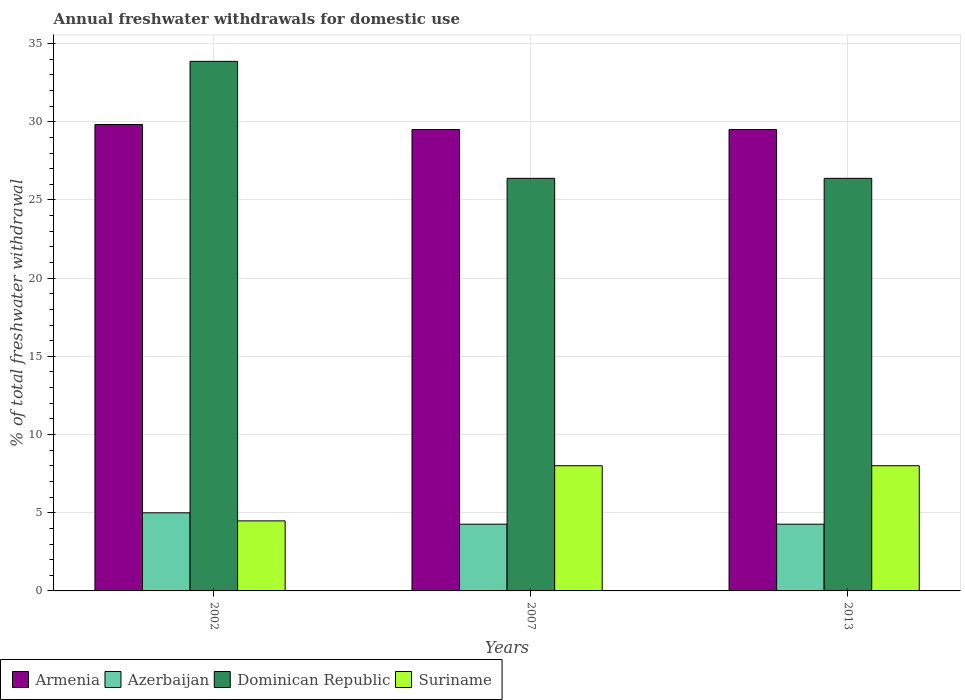How many groups of bars are there?
Keep it short and to the point. 3. Are the number of bars per tick equal to the number of legend labels?
Ensure brevity in your answer.  Yes. Are the number of bars on each tick of the X-axis equal?
Make the answer very short. Yes. How many bars are there on the 1st tick from the left?
Give a very brief answer. 4. How many bars are there on the 3rd tick from the right?
Provide a short and direct response. 4. In how many cases, is the number of bars for a given year not equal to the number of legend labels?
Provide a succinct answer. 0. What is the total annual withdrawals from freshwater in Armenia in 2013?
Your answer should be very brief. 29.5. Across all years, what is the maximum total annual withdrawals from freshwater in Suriname?
Your response must be concise. 8.01. Across all years, what is the minimum total annual withdrawals from freshwater in Dominican Republic?
Your answer should be very brief. 26.38. What is the total total annual withdrawals from freshwater in Suriname in the graph?
Your response must be concise. 20.49. What is the difference between the total annual withdrawals from freshwater in Suriname in 2002 and that in 2013?
Provide a short and direct response. -3.53. What is the difference between the total annual withdrawals from freshwater in Suriname in 2007 and the total annual withdrawals from freshwater in Azerbaijan in 2002?
Your response must be concise. 3.01. What is the average total annual withdrawals from freshwater in Suriname per year?
Ensure brevity in your answer.  6.83. In the year 2002, what is the difference between the total annual withdrawals from freshwater in Armenia and total annual withdrawals from freshwater in Azerbaijan?
Offer a terse response. 24.82. In how many years, is the total annual withdrawals from freshwater in Azerbaijan greater than 25 %?
Make the answer very short. 0. What is the ratio of the total annual withdrawals from freshwater in Azerbaijan in 2007 to that in 2013?
Provide a short and direct response. 1. Is the total annual withdrawals from freshwater in Armenia in 2007 less than that in 2013?
Provide a short and direct response. No. Is the difference between the total annual withdrawals from freshwater in Armenia in 2007 and 2013 greater than the difference between the total annual withdrawals from freshwater in Azerbaijan in 2007 and 2013?
Offer a very short reply. No. What is the difference between the highest and the lowest total annual withdrawals from freshwater in Azerbaijan?
Keep it short and to the point. 0.73. In how many years, is the total annual withdrawals from freshwater in Suriname greater than the average total annual withdrawals from freshwater in Suriname taken over all years?
Your response must be concise. 2. Is the sum of the total annual withdrawals from freshwater in Dominican Republic in 2007 and 2013 greater than the maximum total annual withdrawals from freshwater in Suriname across all years?
Give a very brief answer. Yes. Is it the case that in every year, the sum of the total annual withdrawals from freshwater in Dominican Republic and total annual withdrawals from freshwater in Armenia is greater than the sum of total annual withdrawals from freshwater in Suriname and total annual withdrawals from freshwater in Azerbaijan?
Your answer should be very brief. Yes. What does the 4th bar from the left in 2002 represents?
Offer a terse response. Suriname. What does the 4th bar from the right in 2007 represents?
Offer a very short reply. Armenia. Is it the case that in every year, the sum of the total annual withdrawals from freshwater in Armenia and total annual withdrawals from freshwater in Suriname is greater than the total annual withdrawals from freshwater in Dominican Republic?
Keep it short and to the point. Yes. Are all the bars in the graph horizontal?
Offer a terse response. No. How many years are there in the graph?
Your answer should be compact. 3. Are the values on the major ticks of Y-axis written in scientific E-notation?
Provide a short and direct response. No. Does the graph contain any zero values?
Provide a short and direct response. No. Where does the legend appear in the graph?
Offer a very short reply. Bottom left. How many legend labels are there?
Make the answer very short. 4. What is the title of the graph?
Make the answer very short. Annual freshwater withdrawals for domestic use. What is the label or title of the X-axis?
Provide a succinct answer. Years. What is the label or title of the Y-axis?
Offer a terse response. % of total freshwater withdrawal. What is the % of total freshwater withdrawal of Armenia in 2002?
Provide a succinct answer. 29.82. What is the % of total freshwater withdrawal of Azerbaijan in 2002?
Offer a terse response. 5. What is the % of total freshwater withdrawal in Dominican Republic in 2002?
Keep it short and to the point. 33.86. What is the % of total freshwater withdrawal in Suriname in 2002?
Provide a short and direct response. 4.48. What is the % of total freshwater withdrawal of Armenia in 2007?
Give a very brief answer. 29.5. What is the % of total freshwater withdrawal of Azerbaijan in 2007?
Your answer should be very brief. 4.27. What is the % of total freshwater withdrawal of Dominican Republic in 2007?
Your answer should be compact. 26.38. What is the % of total freshwater withdrawal of Suriname in 2007?
Offer a very short reply. 8.01. What is the % of total freshwater withdrawal in Armenia in 2013?
Provide a short and direct response. 29.5. What is the % of total freshwater withdrawal of Azerbaijan in 2013?
Your response must be concise. 4.27. What is the % of total freshwater withdrawal of Dominican Republic in 2013?
Give a very brief answer. 26.38. What is the % of total freshwater withdrawal in Suriname in 2013?
Provide a short and direct response. 8.01. Across all years, what is the maximum % of total freshwater withdrawal in Armenia?
Ensure brevity in your answer.  29.82. Across all years, what is the maximum % of total freshwater withdrawal of Azerbaijan?
Keep it short and to the point. 5. Across all years, what is the maximum % of total freshwater withdrawal of Dominican Republic?
Keep it short and to the point. 33.86. Across all years, what is the maximum % of total freshwater withdrawal in Suriname?
Your answer should be very brief. 8.01. Across all years, what is the minimum % of total freshwater withdrawal in Armenia?
Ensure brevity in your answer.  29.5. Across all years, what is the minimum % of total freshwater withdrawal of Azerbaijan?
Offer a terse response. 4.27. Across all years, what is the minimum % of total freshwater withdrawal of Dominican Republic?
Offer a terse response. 26.38. Across all years, what is the minimum % of total freshwater withdrawal of Suriname?
Your answer should be compact. 4.48. What is the total % of total freshwater withdrawal in Armenia in the graph?
Keep it short and to the point. 88.82. What is the total % of total freshwater withdrawal of Azerbaijan in the graph?
Keep it short and to the point. 13.53. What is the total % of total freshwater withdrawal of Dominican Republic in the graph?
Make the answer very short. 86.62. What is the total % of total freshwater withdrawal in Suriname in the graph?
Offer a very short reply. 20.49. What is the difference between the % of total freshwater withdrawal of Armenia in 2002 and that in 2007?
Ensure brevity in your answer.  0.32. What is the difference between the % of total freshwater withdrawal in Azerbaijan in 2002 and that in 2007?
Ensure brevity in your answer.  0.73. What is the difference between the % of total freshwater withdrawal in Dominican Republic in 2002 and that in 2007?
Offer a terse response. 7.48. What is the difference between the % of total freshwater withdrawal in Suriname in 2002 and that in 2007?
Keep it short and to the point. -3.53. What is the difference between the % of total freshwater withdrawal of Armenia in 2002 and that in 2013?
Offer a terse response. 0.32. What is the difference between the % of total freshwater withdrawal of Azerbaijan in 2002 and that in 2013?
Give a very brief answer. 0.73. What is the difference between the % of total freshwater withdrawal in Dominican Republic in 2002 and that in 2013?
Give a very brief answer. 7.48. What is the difference between the % of total freshwater withdrawal of Suriname in 2002 and that in 2013?
Ensure brevity in your answer.  -3.53. What is the difference between the % of total freshwater withdrawal of Azerbaijan in 2007 and that in 2013?
Your answer should be very brief. 0. What is the difference between the % of total freshwater withdrawal in Dominican Republic in 2007 and that in 2013?
Provide a short and direct response. 0. What is the difference between the % of total freshwater withdrawal of Suriname in 2007 and that in 2013?
Offer a very short reply. 0. What is the difference between the % of total freshwater withdrawal of Armenia in 2002 and the % of total freshwater withdrawal of Azerbaijan in 2007?
Provide a short and direct response. 25.55. What is the difference between the % of total freshwater withdrawal in Armenia in 2002 and the % of total freshwater withdrawal in Dominican Republic in 2007?
Offer a terse response. 3.44. What is the difference between the % of total freshwater withdrawal of Armenia in 2002 and the % of total freshwater withdrawal of Suriname in 2007?
Provide a succinct answer. 21.82. What is the difference between the % of total freshwater withdrawal of Azerbaijan in 2002 and the % of total freshwater withdrawal of Dominican Republic in 2007?
Your response must be concise. -21.39. What is the difference between the % of total freshwater withdrawal of Azerbaijan in 2002 and the % of total freshwater withdrawal of Suriname in 2007?
Keep it short and to the point. -3.01. What is the difference between the % of total freshwater withdrawal of Dominican Republic in 2002 and the % of total freshwater withdrawal of Suriname in 2007?
Make the answer very short. 25.86. What is the difference between the % of total freshwater withdrawal in Armenia in 2002 and the % of total freshwater withdrawal in Azerbaijan in 2013?
Offer a terse response. 25.55. What is the difference between the % of total freshwater withdrawal in Armenia in 2002 and the % of total freshwater withdrawal in Dominican Republic in 2013?
Offer a very short reply. 3.44. What is the difference between the % of total freshwater withdrawal in Armenia in 2002 and the % of total freshwater withdrawal in Suriname in 2013?
Ensure brevity in your answer.  21.82. What is the difference between the % of total freshwater withdrawal in Azerbaijan in 2002 and the % of total freshwater withdrawal in Dominican Republic in 2013?
Keep it short and to the point. -21.39. What is the difference between the % of total freshwater withdrawal of Azerbaijan in 2002 and the % of total freshwater withdrawal of Suriname in 2013?
Give a very brief answer. -3.01. What is the difference between the % of total freshwater withdrawal in Dominican Republic in 2002 and the % of total freshwater withdrawal in Suriname in 2013?
Offer a very short reply. 25.86. What is the difference between the % of total freshwater withdrawal of Armenia in 2007 and the % of total freshwater withdrawal of Azerbaijan in 2013?
Make the answer very short. 25.23. What is the difference between the % of total freshwater withdrawal in Armenia in 2007 and the % of total freshwater withdrawal in Dominican Republic in 2013?
Give a very brief answer. 3.12. What is the difference between the % of total freshwater withdrawal in Armenia in 2007 and the % of total freshwater withdrawal in Suriname in 2013?
Keep it short and to the point. 21.5. What is the difference between the % of total freshwater withdrawal of Azerbaijan in 2007 and the % of total freshwater withdrawal of Dominican Republic in 2013?
Ensure brevity in your answer.  -22.11. What is the difference between the % of total freshwater withdrawal of Azerbaijan in 2007 and the % of total freshwater withdrawal of Suriname in 2013?
Give a very brief answer. -3.74. What is the difference between the % of total freshwater withdrawal of Dominican Republic in 2007 and the % of total freshwater withdrawal of Suriname in 2013?
Your answer should be compact. 18.38. What is the average % of total freshwater withdrawal of Armenia per year?
Your answer should be compact. 29.61. What is the average % of total freshwater withdrawal of Azerbaijan per year?
Ensure brevity in your answer.  4.51. What is the average % of total freshwater withdrawal in Dominican Republic per year?
Your answer should be compact. 28.87. What is the average % of total freshwater withdrawal in Suriname per year?
Provide a succinct answer. 6.83. In the year 2002, what is the difference between the % of total freshwater withdrawal of Armenia and % of total freshwater withdrawal of Azerbaijan?
Make the answer very short. 24.82. In the year 2002, what is the difference between the % of total freshwater withdrawal in Armenia and % of total freshwater withdrawal in Dominican Republic?
Offer a terse response. -4.04. In the year 2002, what is the difference between the % of total freshwater withdrawal in Armenia and % of total freshwater withdrawal in Suriname?
Provide a succinct answer. 25.34. In the year 2002, what is the difference between the % of total freshwater withdrawal of Azerbaijan and % of total freshwater withdrawal of Dominican Republic?
Keep it short and to the point. -28.86. In the year 2002, what is the difference between the % of total freshwater withdrawal in Azerbaijan and % of total freshwater withdrawal in Suriname?
Your answer should be very brief. 0.52. In the year 2002, what is the difference between the % of total freshwater withdrawal of Dominican Republic and % of total freshwater withdrawal of Suriname?
Offer a terse response. 29.38. In the year 2007, what is the difference between the % of total freshwater withdrawal in Armenia and % of total freshwater withdrawal in Azerbaijan?
Provide a succinct answer. 25.23. In the year 2007, what is the difference between the % of total freshwater withdrawal of Armenia and % of total freshwater withdrawal of Dominican Republic?
Provide a succinct answer. 3.12. In the year 2007, what is the difference between the % of total freshwater withdrawal of Armenia and % of total freshwater withdrawal of Suriname?
Your answer should be compact. 21.5. In the year 2007, what is the difference between the % of total freshwater withdrawal in Azerbaijan and % of total freshwater withdrawal in Dominican Republic?
Your response must be concise. -22.11. In the year 2007, what is the difference between the % of total freshwater withdrawal of Azerbaijan and % of total freshwater withdrawal of Suriname?
Keep it short and to the point. -3.74. In the year 2007, what is the difference between the % of total freshwater withdrawal in Dominican Republic and % of total freshwater withdrawal in Suriname?
Offer a terse response. 18.38. In the year 2013, what is the difference between the % of total freshwater withdrawal in Armenia and % of total freshwater withdrawal in Azerbaijan?
Keep it short and to the point. 25.23. In the year 2013, what is the difference between the % of total freshwater withdrawal of Armenia and % of total freshwater withdrawal of Dominican Republic?
Your answer should be compact. 3.12. In the year 2013, what is the difference between the % of total freshwater withdrawal of Armenia and % of total freshwater withdrawal of Suriname?
Provide a short and direct response. 21.5. In the year 2013, what is the difference between the % of total freshwater withdrawal of Azerbaijan and % of total freshwater withdrawal of Dominican Republic?
Your answer should be very brief. -22.11. In the year 2013, what is the difference between the % of total freshwater withdrawal in Azerbaijan and % of total freshwater withdrawal in Suriname?
Your answer should be very brief. -3.74. In the year 2013, what is the difference between the % of total freshwater withdrawal in Dominican Republic and % of total freshwater withdrawal in Suriname?
Your answer should be very brief. 18.38. What is the ratio of the % of total freshwater withdrawal of Armenia in 2002 to that in 2007?
Your answer should be very brief. 1.01. What is the ratio of the % of total freshwater withdrawal of Azerbaijan in 2002 to that in 2007?
Offer a terse response. 1.17. What is the ratio of the % of total freshwater withdrawal of Dominican Republic in 2002 to that in 2007?
Your response must be concise. 1.28. What is the ratio of the % of total freshwater withdrawal of Suriname in 2002 to that in 2007?
Make the answer very short. 0.56. What is the ratio of the % of total freshwater withdrawal in Armenia in 2002 to that in 2013?
Make the answer very short. 1.01. What is the ratio of the % of total freshwater withdrawal in Azerbaijan in 2002 to that in 2013?
Offer a terse response. 1.17. What is the ratio of the % of total freshwater withdrawal in Dominican Republic in 2002 to that in 2013?
Ensure brevity in your answer.  1.28. What is the ratio of the % of total freshwater withdrawal in Suriname in 2002 to that in 2013?
Offer a very short reply. 0.56. What is the ratio of the % of total freshwater withdrawal in Armenia in 2007 to that in 2013?
Provide a short and direct response. 1. What is the ratio of the % of total freshwater withdrawal in Suriname in 2007 to that in 2013?
Your response must be concise. 1. What is the difference between the highest and the second highest % of total freshwater withdrawal in Armenia?
Provide a succinct answer. 0.32. What is the difference between the highest and the second highest % of total freshwater withdrawal of Azerbaijan?
Provide a short and direct response. 0.73. What is the difference between the highest and the second highest % of total freshwater withdrawal of Dominican Republic?
Offer a terse response. 7.48. What is the difference between the highest and the second highest % of total freshwater withdrawal of Suriname?
Offer a terse response. 0. What is the difference between the highest and the lowest % of total freshwater withdrawal of Armenia?
Ensure brevity in your answer.  0.32. What is the difference between the highest and the lowest % of total freshwater withdrawal of Azerbaijan?
Ensure brevity in your answer.  0.73. What is the difference between the highest and the lowest % of total freshwater withdrawal in Dominican Republic?
Your answer should be compact. 7.48. What is the difference between the highest and the lowest % of total freshwater withdrawal in Suriname?
Make the answer very short. 3.53. 